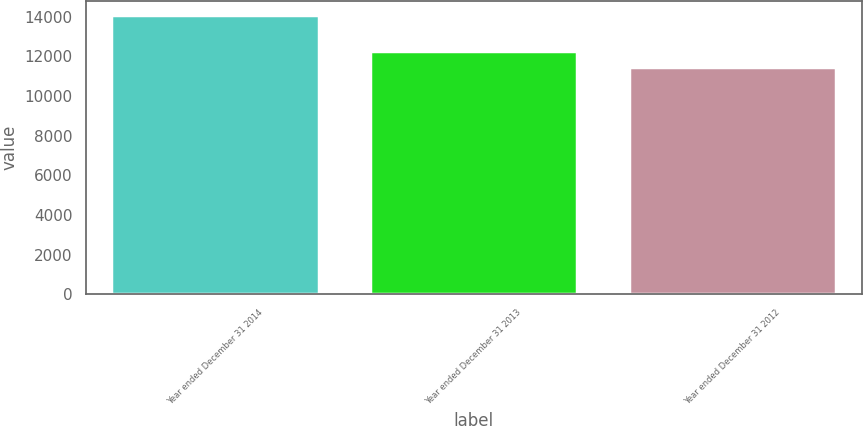Convert chart to OTSL. <chart><loc_0><loc_0><loc_500><loc_500><bar_chart><fcel>Year ended December 31 2014<fcel>Year ended December 31 2013<fcel>Year ended December 31 2012<nl><fcel>14094<fcel>12278<fcel>11461<nl></chart> 